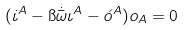Convert formula to latex. <formula><loc_0><loc_0><loc_500><loc_500>( \dot { \iota } ^ { A } - \i \dot { \bar { \omega } } \iota ^ { A } - \acute { o } ^ { A } ) o _ { A } = 0</formula> 